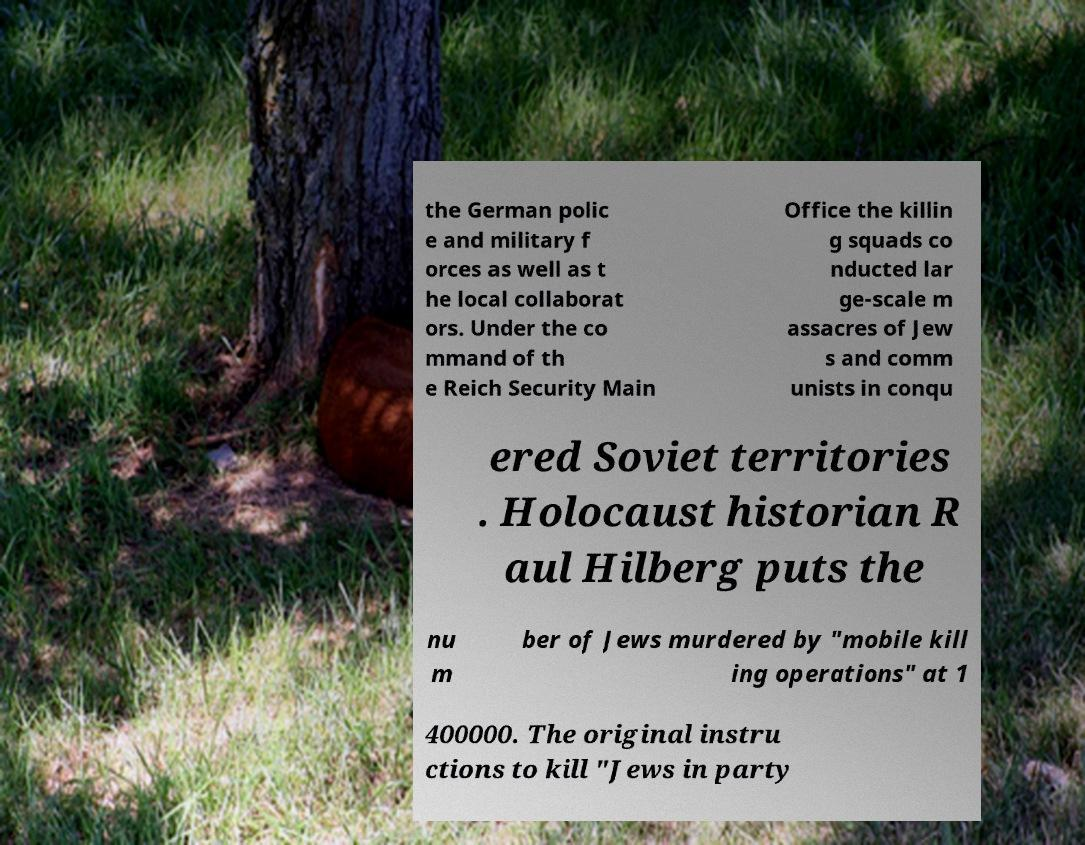Please read and relay the text visible in this image. What does it say? the German polic e and military f orces as well as t he local collaborat ors. Under the co mmand of th e Reich Security Main Office the killin g squads co nducted lar ge-scale m assacres of Jew s and comm unists in conqu ered Soviet territories . Holocaust historian R aul Hilberg puts the nu m ber of Jews murdered by "mobile kill ing operations" at 1 400000. The original instru ctions to kill "Jews in party 